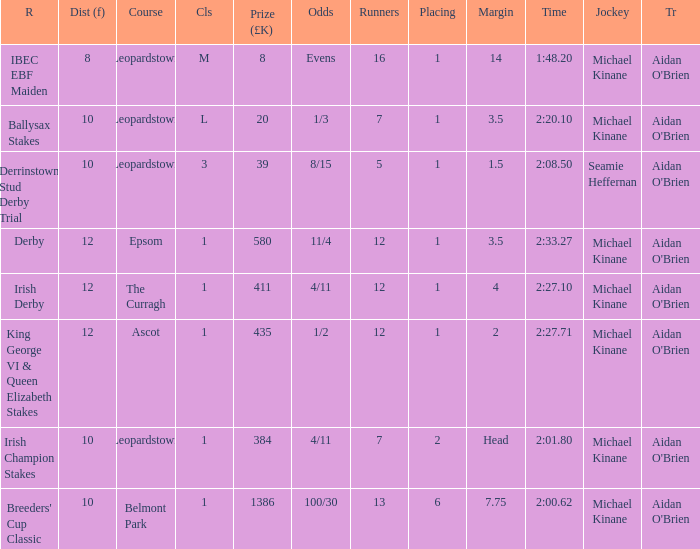Which Dist (f) has a Race of irish derby? 12.0. 